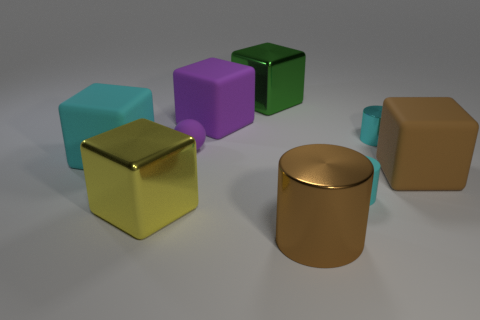Subtract 1 cubes. How many cubes are left? 4 Subtract all big purple cubes. How many cubes are left? 4 Subtract all cyan cubes. How many cubes are left? 4 Subtract all red cubes. Subtract all blue cylinders. How many cubes are left? 5 Subtract all cylinders. How many objects are left? 6 Add 3 tiny yellow rubber cubes. How many tiny yellow rubber cubes exist? 3 Subtract 0 blue blocks. How many objects are left? 9 Subtract all big blue things. Subtract all purple things. How many objects are left? 7 Add 2 large brown blocks. How many large brown blocks are left? 3 